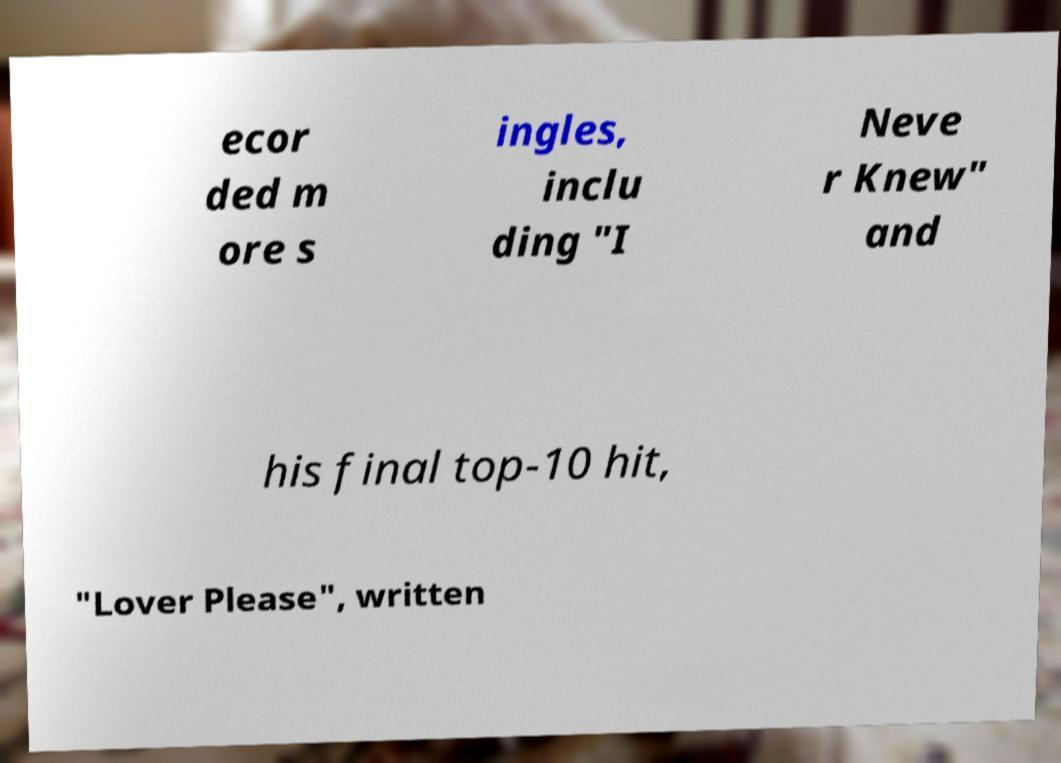For documentation purposes, I need the text within this image transcribed. Could you provide that? ecor ded m ore s ingles, inclu ding "I Neve r Knew" and his final top-10 hit, "Lover Please", written 